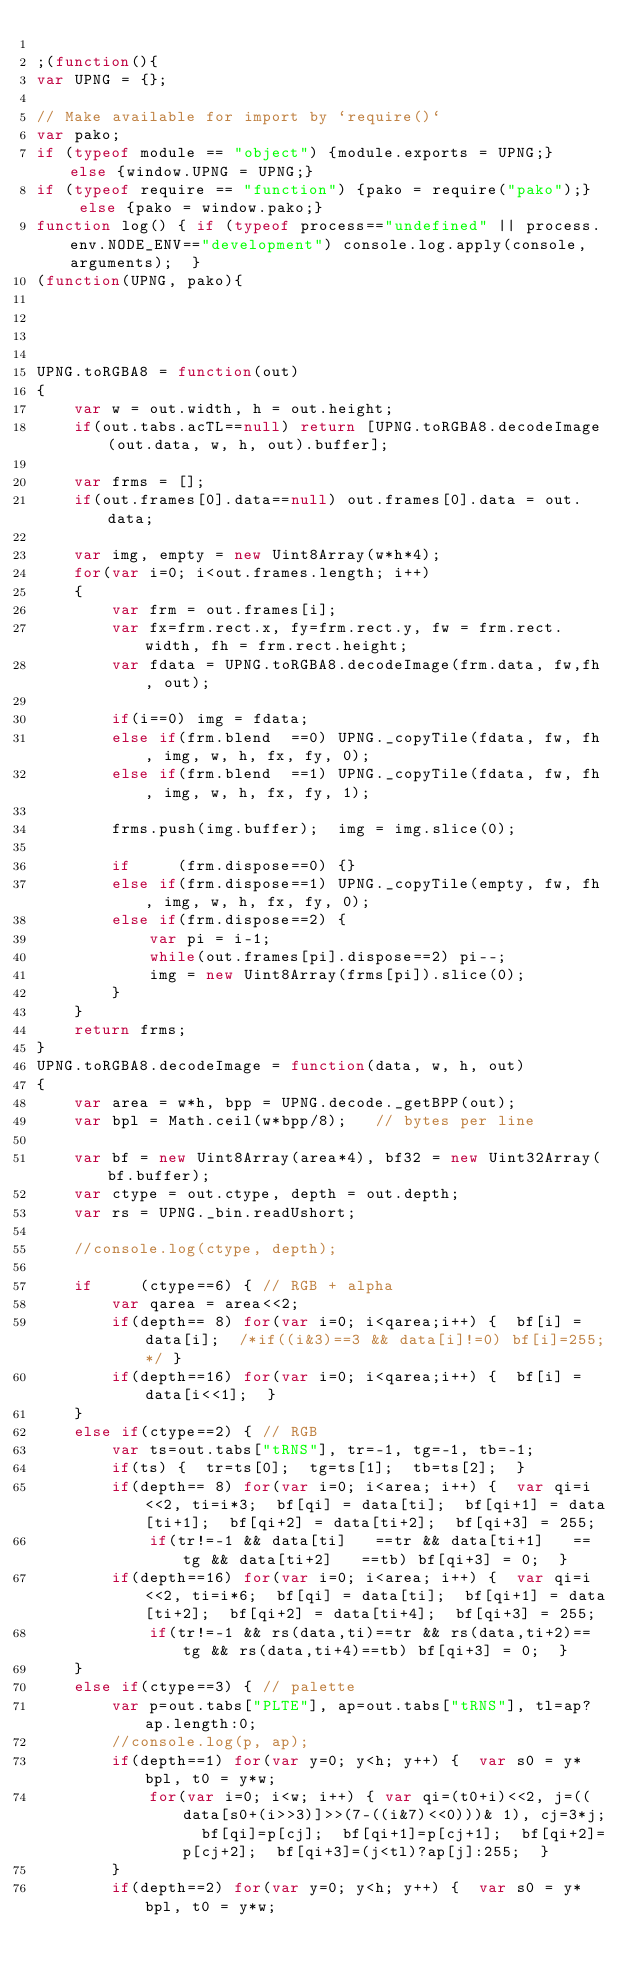Convert code to text. <code><loc_0><loc_0><loc_500><loc_500><_JavaScript_>
;(function(){
var UPNG = {};

// Make available for import by `require()`
var pako;
if (typeof module == "object") {module.exports = UPNG;}  else {window.UPNG = UPNG;}
if (typeof require == "function") {pako = require("pako");}  else {pako = window.pako;}
function log() { if (typeof process=="undefined" || process.env.NODE_ENV=="development") console.log.apply(console, arguments);  }
(function(UPNG, pako){


	

UPNG.toRGBA8 = function(out)
{
	var w = out.width, h = out.height;
	if(out.tabs.acTL==null) return [UPNG.toRGBA8.decodeImage(out.data, w, h, out).buffer];
	
	var frms = [];
	if(out.frames[0].data==null) out.frames[0].data = out.data;
	
	var img, empty = new Uint8Array(w*h*4);
	for(var i=0; i<out.frames.length; i++)
	{
		var frm = out.frames[i];
		var fx=frm.rect.x, fy=frm.rect.y, fw = frm.rect.width, fh = frm.rect.height;
		var fdata = UPNG.toRGBA8.decodeImage(frm.data, fw,fh, out);
		
		if(i==0) img = fdata;
		else if(frm.blend  ==0) UPNG._copyTile(fdata, fw, fh, img, w, h, fx, fy, 0);
		else if(frm.blend  ==1) UPNG._copyTile(fdata, fw, fh, img, w, h, fx, fy, 1);
		
		frms.push(img.buffer);  img = img.slice(0);
		
		if     (frm.dispose==0) {}
		else if(frm.dispose==1) UPNG._copyTile(empty, fw, fh, img, w, h, fx, fy, 0);
		else if(frm.dispose==2) {
			var pi = i-1;
			while(out.frames[pi].dispose==2) pi--;
			img = new Uint8Array(frms[pi]).slice(0);
		}
	}
	return frms;
}
UPNG.toRGBA8.decodeImage = function(data, w, h, out)
{
	var area = w*h, bpp = UPNG.decode._getBPP(out);
	var bpl = Math.ceil(w*bpp/8);	// bytes per line

	var bf = new Uint8Array(area*4), bf32 = new Uint32Array(bf.buffer);
	var ctype = out.ctype, depth = out.depth;
	var rs = UPNG._bin.readUshort;
	
	//console.log(ctype, depth);

	if     (ctype==6) { // RGB + alpha
		var qarea = area<<2;
		if(depth== 8) for(var i=0; i<qarea;i++) {  bf[i] = data[i];  /*if((i&3)==3 && data[i]!=0) bf[i]=255;*/ }
		if(depth==16) for(var i=0; i<qarea;i++) {  bf[i] = data[i<<1];  }
	}
	else if(ctype==2) {	// RGB
		var ts=out.tabs["tRNS"], tr=-1, tg=-1, tb=-1;
		if(ts) {  tr=ts[0];  tg=ts[1];  tb=ts[2];  }
		if(depth== 8) for(var i=0; i<area; i++) {  var qi=i<<2, ti=i*3;  bf[qi] = data[ti];  bf[qi+1] = data[ti+1];  bf[qi+2] = data[ti+2];  bf[qi+3] = 255;
			if(tr!=-1 && data[ti]   ==tr && data[ti+1]   ==tg && data[ti+2]   ==tb) bf[qi+3] = 0;  }
		if(depth==16) for(var i=0; i<area; i++) {  var qi=i<<2, ti=i*6;  bf[qi] = data[ti];  bf[qi+1] = data[ti+2];  bf[qi+2] = data[ti+4];  bf[qi+3] = 255;
			if(tr!=-1 && rs(data,ti)==tr && rs(data,ti+2)==tg && rs(data,ti+4)==tb) bf[qi+3] = 0;  }
	}
	else if(ctype==3) {	// palette
		var p=out.tabs["PLTE"], ap=out.tabs["tRNS"], tl=ap?ap.length:0;
		//console.log(p, ap);
		if(depth==1) for(var y=0; y<h; y++) {  var s0 = y*bpl, t0 = y*w;
			for(var i=0; i<w; i++) { var qi=(t0+i)<<2, j=((data[s0+(i>>3)]>>(7-((i&7)<<0)))& 1), cj=3*j;  bf[qi]=p[cj];  bf[qi+1]=p[cj+1];  bf[qi+2]=p[cj+2];  bf[qi+3]=(j<tl)?ap[j]:255;  }
		}
		if(depth==2) for(var y=0; y<h; y++) {  var s0 = y*bpl, t0 = y*w;</code> 